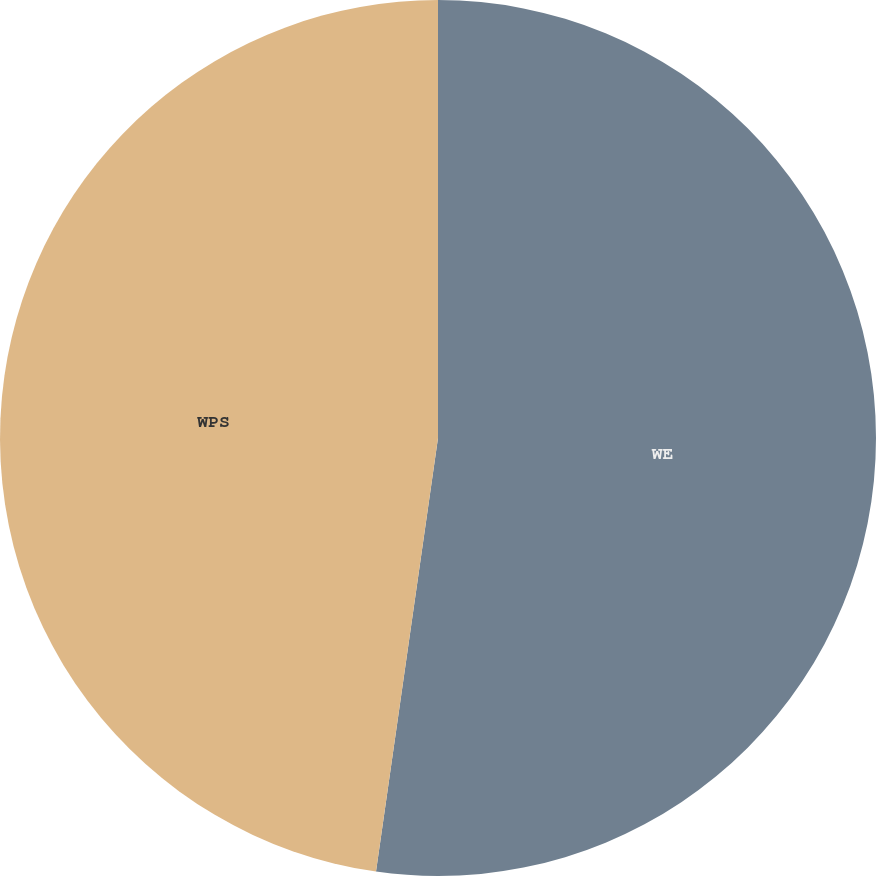Convert chart. <chart><loc_0><loc_0><loc_500><loc_500><pie_chart><fcel>WE<fcel>WPS<nl><fcel>52.26%<fcel>47.74%<nl></chart> 